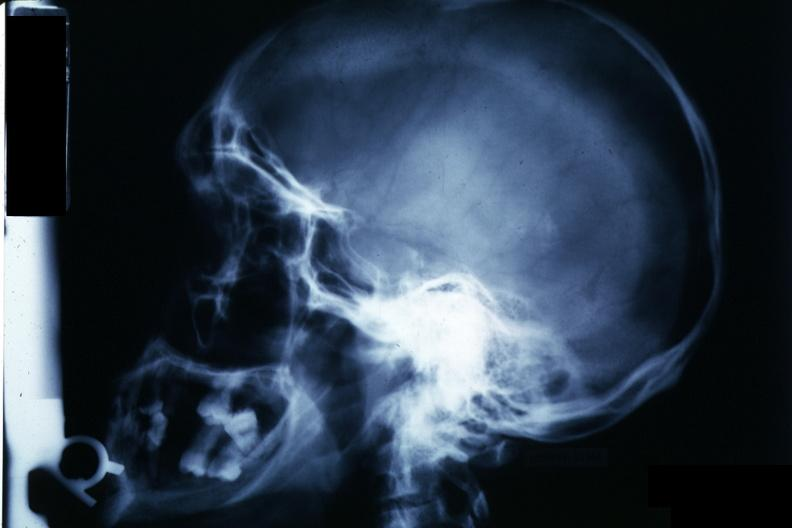what does this image show?
Answer the question using a single word or phrase. X-ray sella 